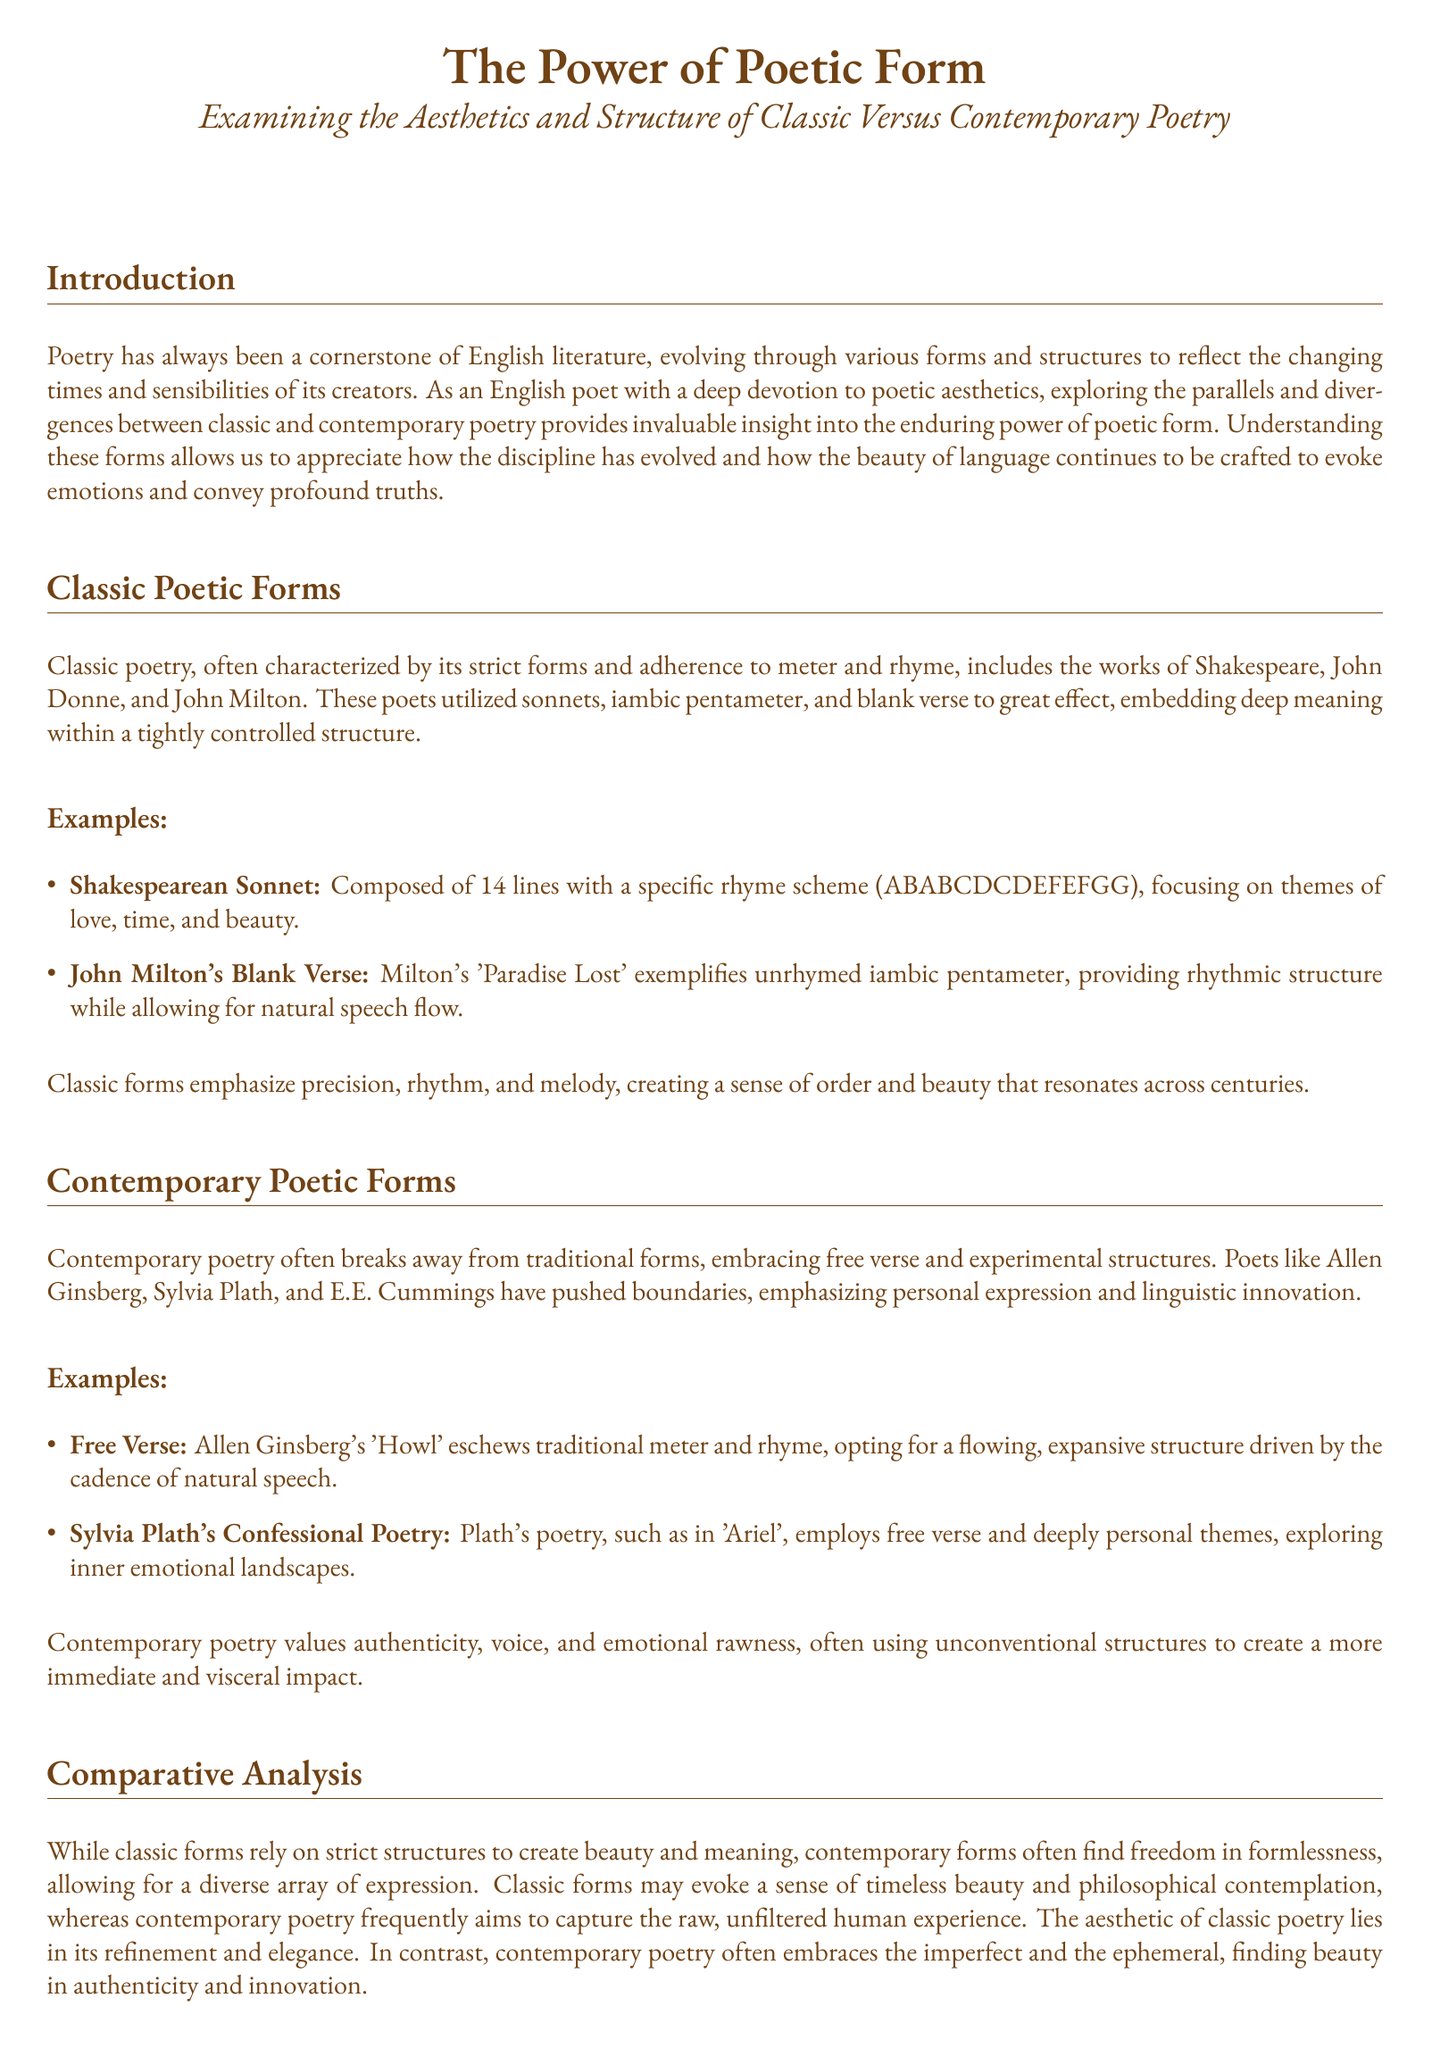What is the main focus of the paper? The paper focuses on examining the aesthetics and structure of classic versus contemporary poetry.
Answer: Aesthetics and structure Who are two poets mentioned under classic poetic forms? The document lists Shakespeare and John Donne as classic poets.
Answer: Shakespeare and John Donne What poetic form is exemplified by John Milton's 'Paradise Lost'? The document states that 'Paradise Lost' exemplifies unrhymed iambic pentameter.
Answer: Blank verse Name one characteristic of contemporary poetry as mentioned in the document. The document highlights that contemporary poetry often embraces free verse and experimental structures.
Answer: Free verse What year does the document reference for when poetry evolves? The document does not specify a year but refers generally to poetry's evolution across time.
Answer: Not specified According to the comparative analysis, what do classic forms create? The document indicates that classic forms create beauty and meaning through strict structures.
Answer: Beauty and meaning In what type of themes does Sylvia Plath's poetry engage? The document describes Plath's poetry as deeply personal, exploring inner emotional landscapes.
Answer: Deeply personal themes How many lines are in a Shakespearean sonnet? The document states that a Shakespearean sonnet is composed of 14 lines.
Answer: 14 lines What term describes the style of poetry represented by Allen Ginsberg's 'Howl'? The document categorizes 'Howl' as free verse.
Answer: Free verse 